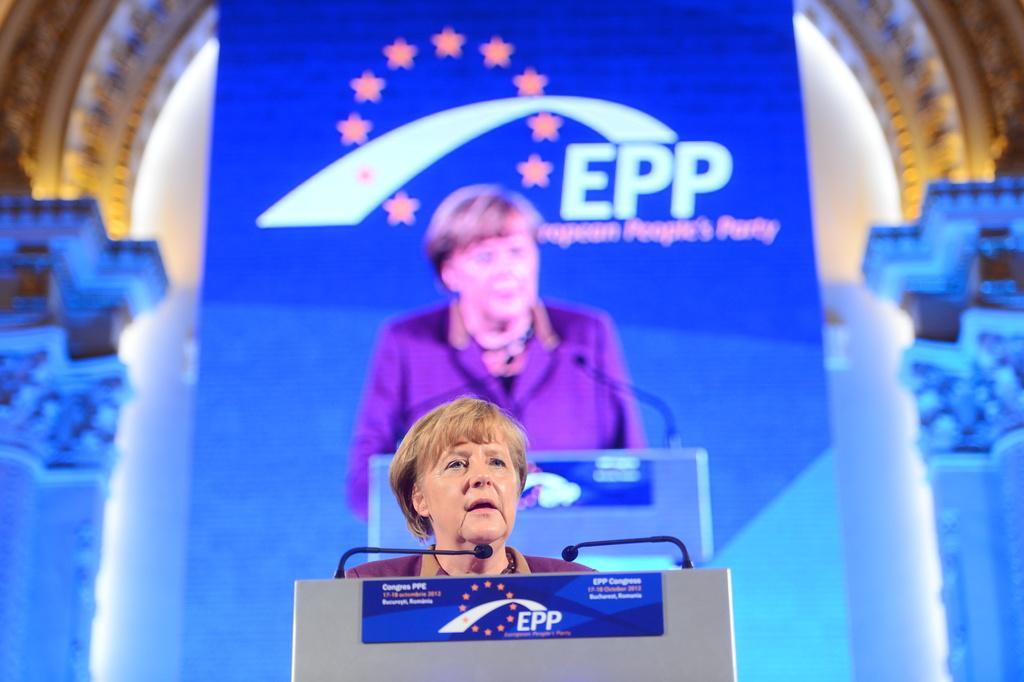Could you give a brief overview of what you see in this image? In this image I can see a person standing in front of podium. I can see two mics and blue color board is attached to it. Background I can see blue and white color board. 